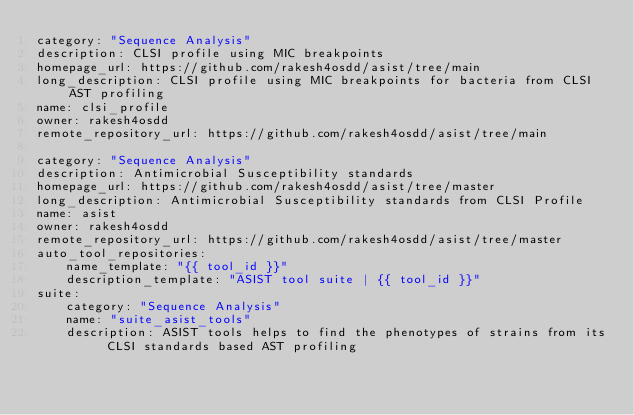<code> <loc_0><loc_0><loc_500><loc_500><_YAML_>category: "Sequence Analysis"
description: CLSI profile using MIC breakpoints
homepage_url: https://github.com/rakesh4osdd/asist/tree/main
long_description: CLSI profile using MIC breakpoints for bacteria from CLSI AST profiling 
name: clsi_profile
owner: rakesh4osdd
remote_repository_url: https://github.com/rakesh4osdd/asist/tree/main

category: "Sequence Analysis"
description: Antimicrobial Susceptibility standards
homepage_url: https://github.com/rakesh4osdd/asist/tree/master
long_description: Antimicrobial Susceptibility standards from CLSI Profile
name: asist
owner: rakesh4osdd
remote_repository_url: https://github.com/rakesh4osdd/asist/tree/master
auto_tool_repositories:
    name_template: "{{ tool_id }}"
    description_template: "ASIST tool suite | {{ tool_id }}"
suite:
    category: "Sequence Analysis"
    name: "suite_asist_tools"
    description: ASIST tools helps to find the phenotypes of strains from its CLSI standards based AST profiling
</code> 